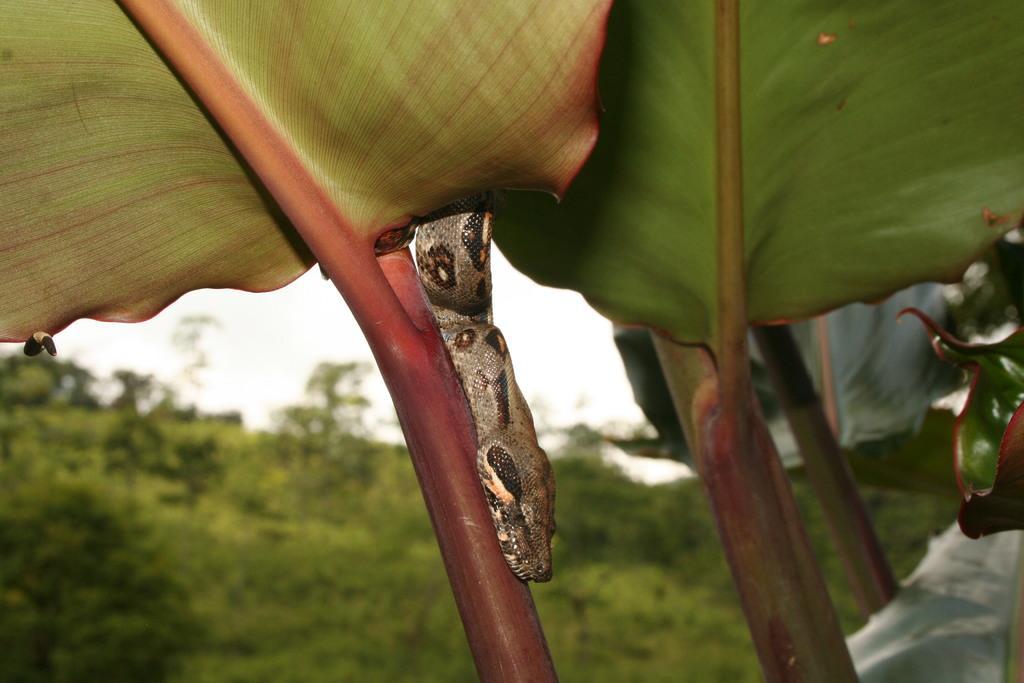Describe this image in one or two sentences. In the image we can see a snake, leaves, stem, white sky and the background is blurred. 